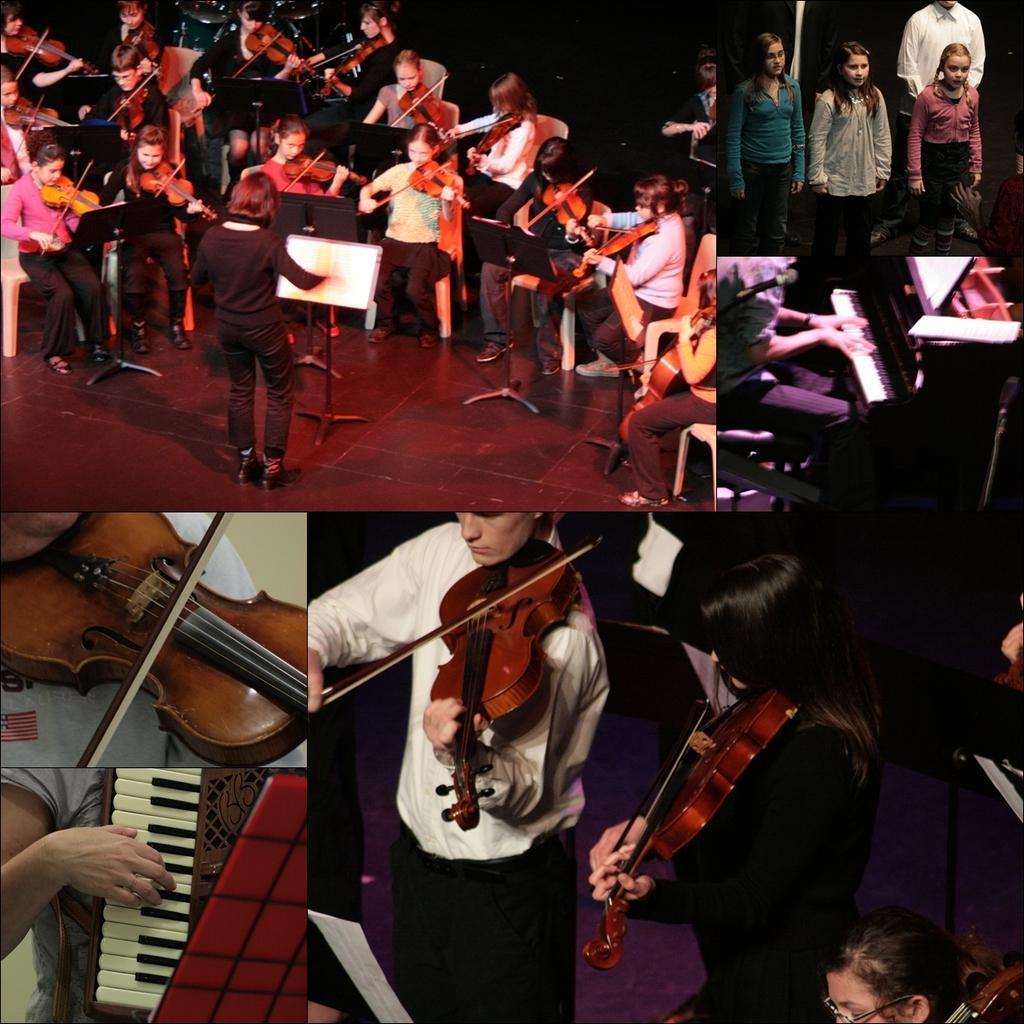Please provide a concise description of this image. This is a collage image. There are six images which are coloured. In the first image there are people playing violin. In the second image there are three girls standing and a man behind them. In the third image there is a person who is playing a piano. In the fourth image there is a person who is playing a violin. In the fifth image there are two people who are playing violin and the last image has a man playing musical instrument. 